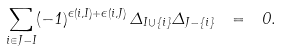<formula> <loc_0><loc_0><loc_500><loc_500>\sum _ { i \in J - I } ( - 1 ) ^ { \epsilon ( i , I ) + \epsilon ( i , J ) } \, \Delta _ { I \cup \{ i \} } \Delta _ { J - \{ i \} } \ = \ 0 .</formula> 